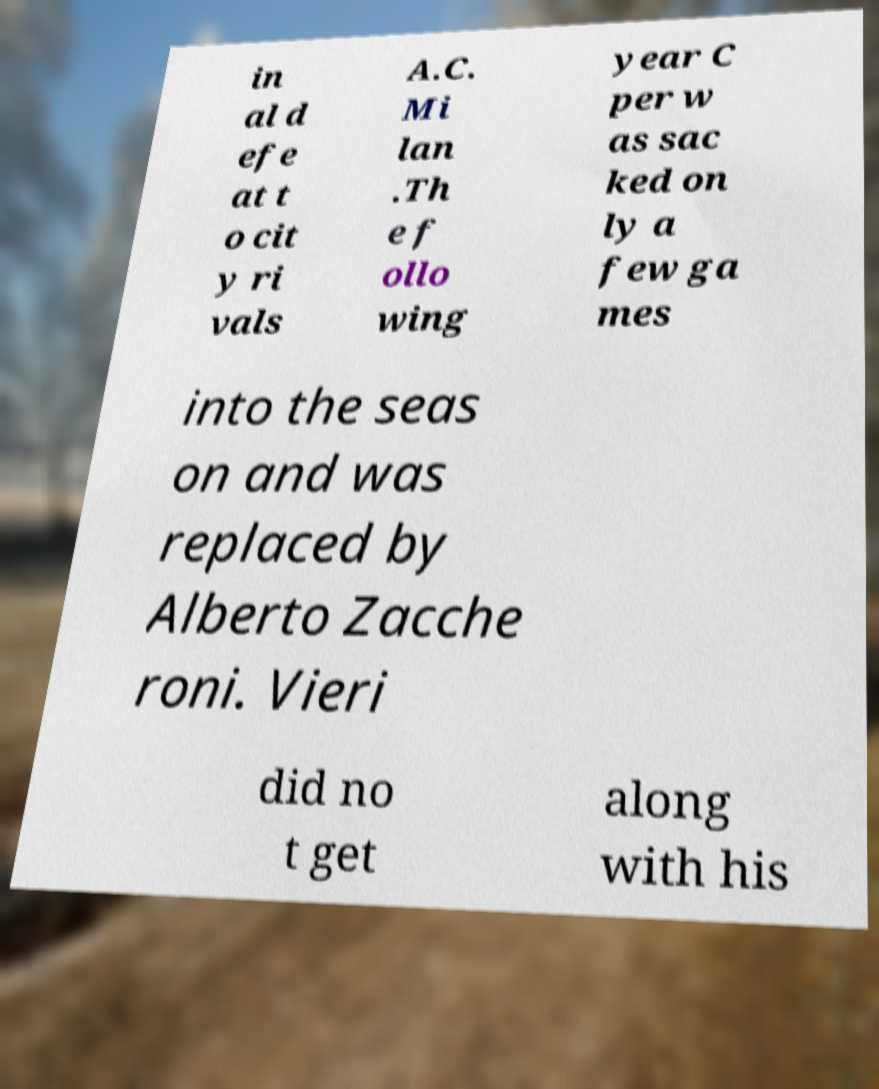Can you accurately transcribe the text from the provided image for me? in al d efe at t o cit y ri vals A.C. Mi lan .Th e f ollo wing year C per w as sac ked on ly a few ga mes into the seas on and was replaced by Alberto Zacche roni. Vieri did no t get along with his 